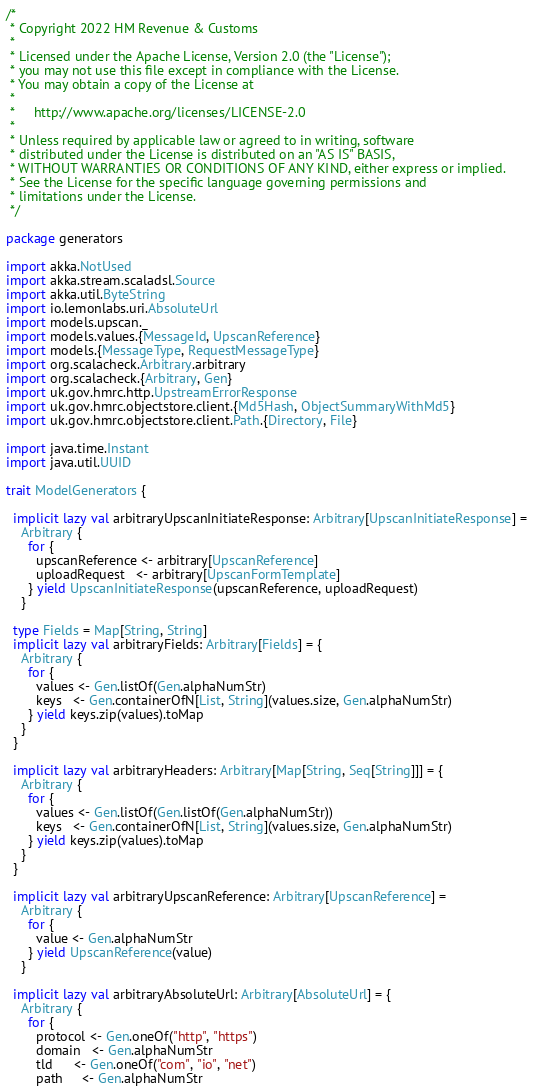<code> <loc_0><loc_0><loc_500><loc_500><_Scala_>/*
 * Copyright 2022 HM Revenue & Customs
 *
 * Licensed under the Apache License, Version 2.0 (the "License");
 * you may not use this file except in compliance with the License.
 * You may obtain a copy of the License at
 *
 *     http://www.apache.org/licenses/LICENSE-2.0
 *
 * Unless required by applicable law or agreed to in writing, software
 * distributed under the License is distributed on an "AS IS" BASIS,
 * WITHOUT WARRANTIES OR CONDITIONS OF ANY KIND, either express or implied.
 * See the License for the specific language governing permissions and
 * limitations under the License.
 */

package generators

import akka.NotUsed
import akka.stream.scaladsl.Source
import akka.util.ByteString
import io.lemonlabs.uri.AbsoluteUrl
import models.upscan._
import models.values.{MessageId, UpscanReference}
import models.{MessageType, RequestMessageType}
import org.scalacheck.Arbitrary.arbitrary
import org.scalacheck.{Arbitrary, Gen}
import uk.gov.hmrc.http.UpstreamErrorResponse
import uk.gov.hmrc.objectstore.client.{Md5Hash, ObjectSummaryWithMd5}
import uk.gov.hmrc.objectstore.client.Path.{Directory, File}

import java.time.Instant
import java.util.UUID

trait ModelGenerators {

  implicit lazy val arbitraryUpscanInitiateResponse: Arbitrary[UpscanInitiateResponse] =
    Arbitrary {
      for {
        upscanReference <- arbitrary[UpscanReference]
        uploadRequest   <- arbitrary[UpscanFormTemplate]
      } yield UpscanInitiateResponse(upscanReference, uploadRequest)
    }

  type Fields = Map[String, String]
  implicit lazy val arbitraryFields: Arbitrary[Fields] = {
    Arbitrary {
      for {
        values <- Gen.listOf(Gen.alphaNumStr)
        keys   <- Gen.containerOfN[List, String](values.size, Gen.alphaNumStr)
      } yield keys.zip(values).toMap
    }
  }

  implicit lazy val arbitraryHeaders: Arbitrary[Map[String, Seq[String]]] = {
    Arbitrary {
      for {
        values <- Gen.listOf(Gen.listOf(Gen.alphaNumStr))
        keys   <- Gen.containerOfN[List, String](values.size, Gen.alphaNumStr)
      } yield keys.zip(values).toMap
    }
  }

  implicit lazy val arbitraryUpscanReference: Arbitrary[UpscanReference] =
    Arbitrary {
      for {
        value <- Gen.alphaNumStr
      } yield UpscanReference(value)
    }

  implicit lazy val arbitraryAbsoluteUrl: Arbitrary[AbsoluteUrl] = {
    Arbitrary {
      for {
        protocol <- Gen.oneOf("http", "https")
        domain   <- Gen.alphaNumStr
        tld      <- Gen.oneOf("com", "io", "net")
        path     <- Gen.alphaNumStr</code> 